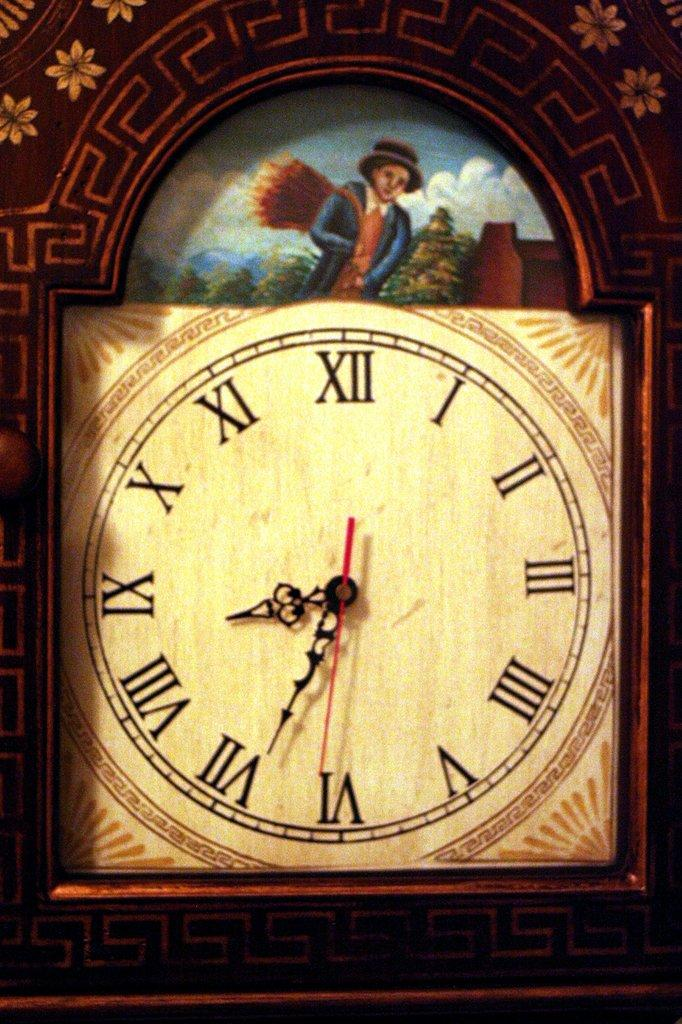<image>
Render a clear and concise summary of the photo. A tan clock shows the time as "8:34." 